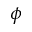<formula> <loc_0><loc_0><loc_500><loc_500>\phi</formula> 